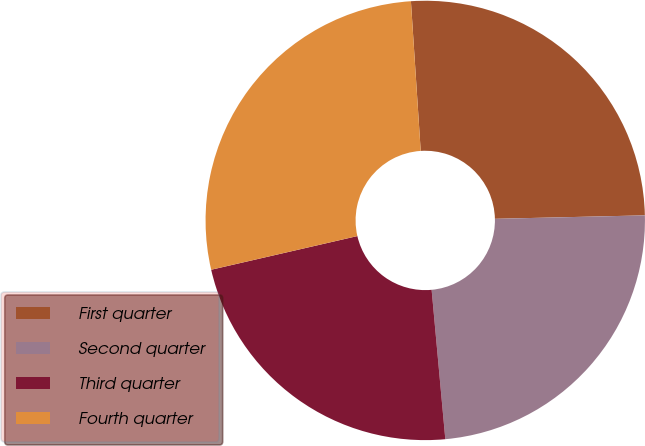Convert chart. <chart><loc_0><loc_0><loc_500><loc_500><pie_chart><fcel>First quarter<fcel>Second quarter<fcel>Third quarter<fcel>Fourth quarter<nl><fcel>25.67%<fcel>23.91%<fcel>22.85%<fcel>27.56%<nl></chart> 